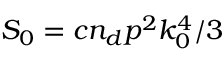Convert formula to latex. <formula><loc_0><loc_0><loc_500><loc_500>S _ { 0 } = c n _ { d } p ^ { 2 } k _ { 0 } ^ { 4 } / 3</formula> 